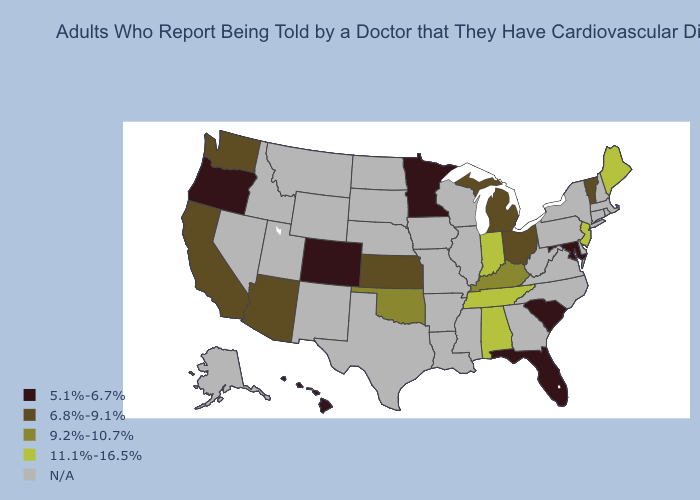Among the states that border Arkansas , which have the highest value?
Be succinct. Tennessee. What is the value of Kansas?
Concise answer only. 6.8%-9.1%. Does Vermont have the lowest value in the Northeast?
Write a very short answer. Yes. What is the value of Washington?
Be succinct. 6.8%-9.1%. Which states have the highest value in the USA?
Give a very brief answer. Alabama, Indiana, Maine, New Jersey, Tennessee. Does the first symbol in the legend represent the smallest category?
Write a very short answer. Yes. Among the states that border Michigan , does Ohio have the highest value?
Quick response, please. No. Name the states that have a value in the range N/A?
Concise answer only. Alaska, Arkansas, Connecticut, Delaware, Georgia, Idaho, Illinois, Iowa, Louisiana, Massachusetts, Mississippi, Missouri, Montana, Nebraska, Nevada, New Hampshire, New Mexico, New York, North Carolina, North Dakota, Pennsylvania, Rhode Island, South Dakota, Texas, Utah, Virginia, West Virginia, Wisconsin, Wyoming. What is the lowest value in the USA?
Quick response, please. 5.1%-6.7%. What is the value of Washington?
Keep it brief. 6.8%-9.1%. Which states have the lowest value in the USA?
Keep it brief. Colorado, Florida, Hawaii, Maryland, Minnesota, Oregon, South Carolina. Name the states that have a value in the range 9.2%-10.7%?
Write a very short answer. Kentucky, Oklahoma. Name the states that have a value in the range 6.8%-9.1%?
Concise answer only. Arizona, California, Kansas, Michigan, Ohio, Vermont, Washington. Name the states that have a value in the range 11.1%-16.5%?
Answer briefly. Alabama, Indiana, Maine, New Jersey, Tennessee. Name the states that have a value in the range N/A?
Be succinct. Alaska, Arkansas, Connecticut, Delaware, Georgia, Idaho, Illinois, Iowa, Louisiana, Massachusetts, Mississippi, Missouri, Montana, Nebraska, Nevada, New Hampshire, New Mexico, New York, North Carolina, North Dakota, Pennsylvania, Rhode Island, South Dakota, Texas, Utah, Virginia, West Virginia, Wisconsin, Wyoming. 